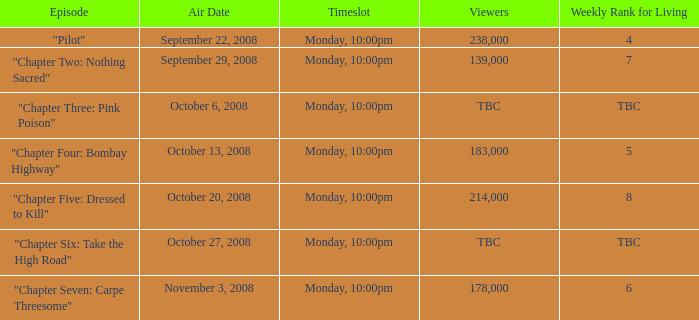How many viewers for the episode with a weekly ranking of 4 for living? 238000.0. 